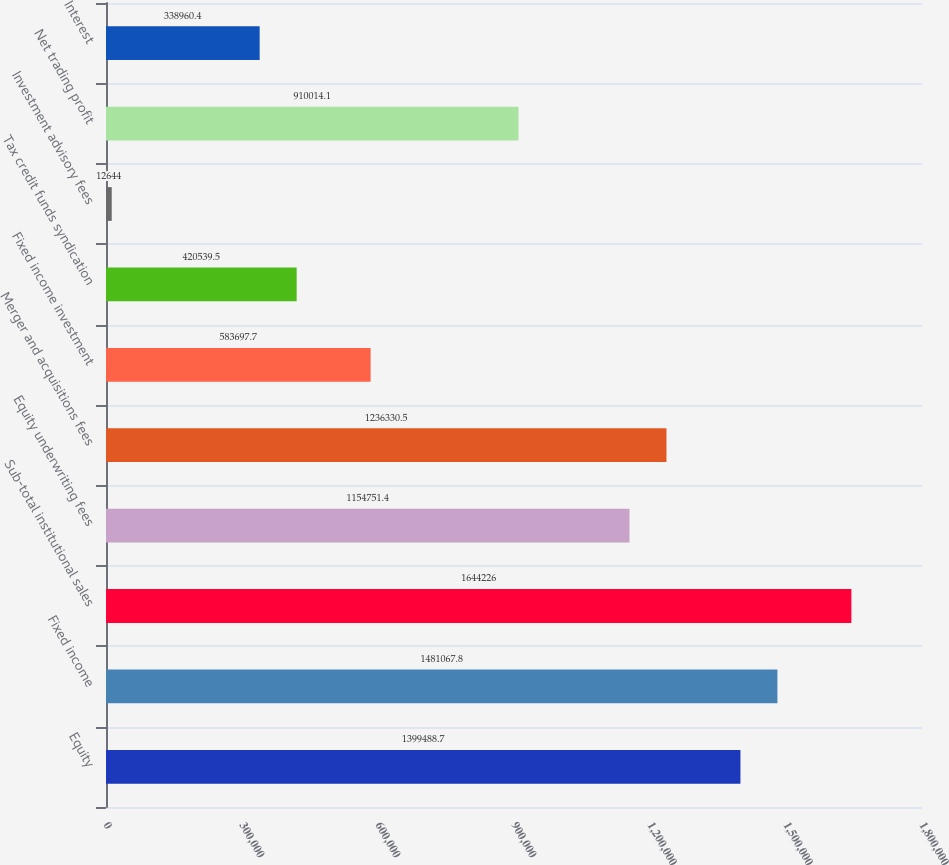Convert chart. <chart><loc_0><loc_0><loc_500><loc_500><bar_chart><fcel>Equity<fcel>Fixed income<fcel>Sub-total institutional sales<fcel>Equity underwriting fees<fcel>Merger and acquisitions fees<fcel>Fixed income investment<fcel>Tax credit funds syndication<fcel>Investment advisory fees<fcel>Net trading profit<fcel>Interest<nl><fcel>1.39949e+06<fcel>1.48107e+06<fcel>1.64423e+06<fcel>1.15475e+06<fcel>1.23633e+06<fcel>583698<fcel>420540<fcel>12644<fcel>910014<fcel>338960<nl></chart> 